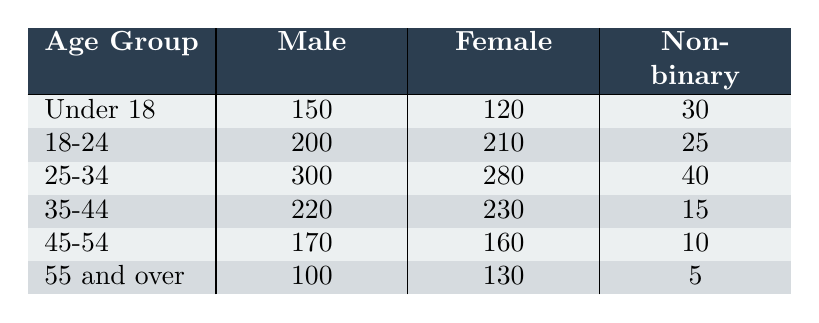What is the number of males in the 25-34 age group? The table shows that in the 25-34 age group, the number of males is listed as 300.
Answer: 300 What is the total number of females across all age groups? To find the total number of females, sum the female counts from each age group: 120 + 210 + 280 + 230 + 160 + 130 = 1130.
Answer: 1130 Is there a higher number of non-binary individuals in the 18-24 age group compared to the 55 and over age group? The non-binary count in the 18-24 age group is 25, while in the 55 and over age group it is 5. Since 25 > 5, the answer is yes.
Answer: Yes What is the age group with the highest total audience count? To determine this, calculate the total for each age group by summing males, females, and non-binary individuals. The highest total is 300 (Male) + 280 (Female) + 40 (Non-binary) = 620 for the 25-34 age group.
Answer: 25-34 What is the difference in the number of males between the 18-24 and 35-44 age groups? The number of males in the 18-24 age group is 200, and in the 35-44 age group, it is 220. The difference is 220 - 200 = 20.
Answer: 20 